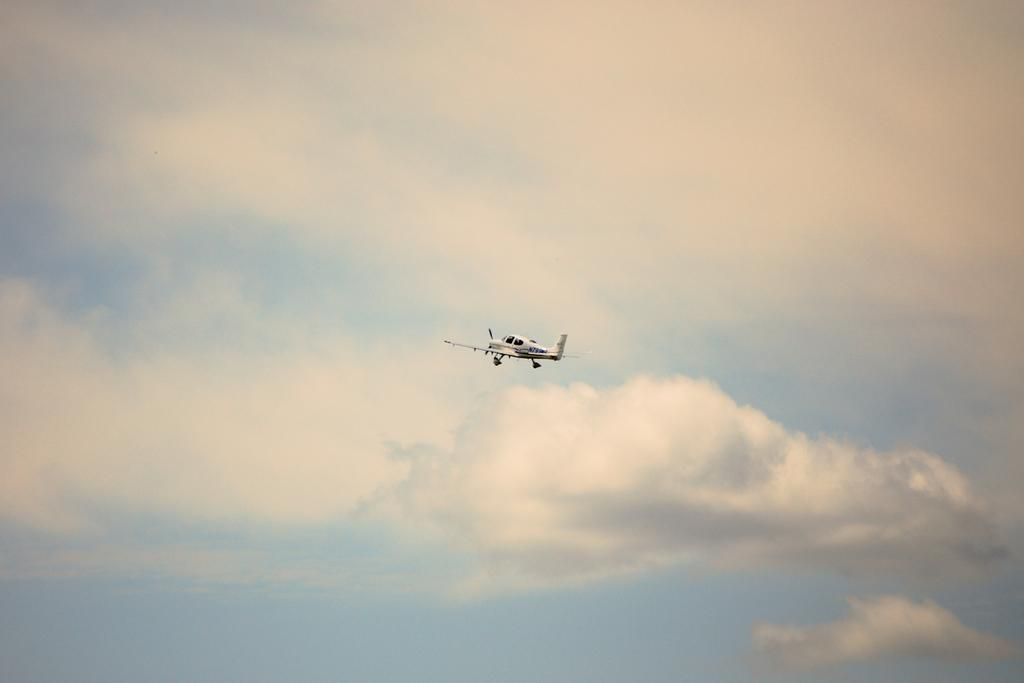What is the main subject of the image? The main subject of the image is an aircraft. What color is the aircraft? The aircraft is white in color. Where is the aircraft located in the image? The aircraft is in the air. What can be seen in the background of the image? There are clouds and the sky visible in the background of the image. How many cacti are present on the hill in the image? There are no cacti or hills present in the image; it features an aircraft in the air. 